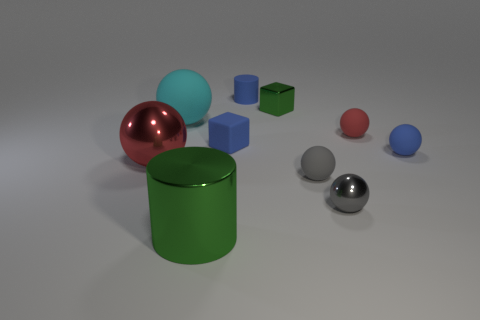Subtract all big spheres. How many spheres are left? 4 Subtract all green blocks. How many blocks are left? 1 Subtract all blocks. How many objects are left? 8 Subtract 0 purple blocks. How many objects are left? 10 Subtract 6 balls. How many balls are left? 0 Subtract all cyan cubes. Subtract all cyan spheres. How many cubes are left? 2 Subtract all purple balls. How many blue cubes are left? 1 Subtract all big cyan matte objects. Subtract all small gray rubber spheres. How many objects are left? 8 Add 9 blue balls. How many blue balls are left? 10 Add 4 small brown matte cubes. How many small brown matte cubes exist? 4 